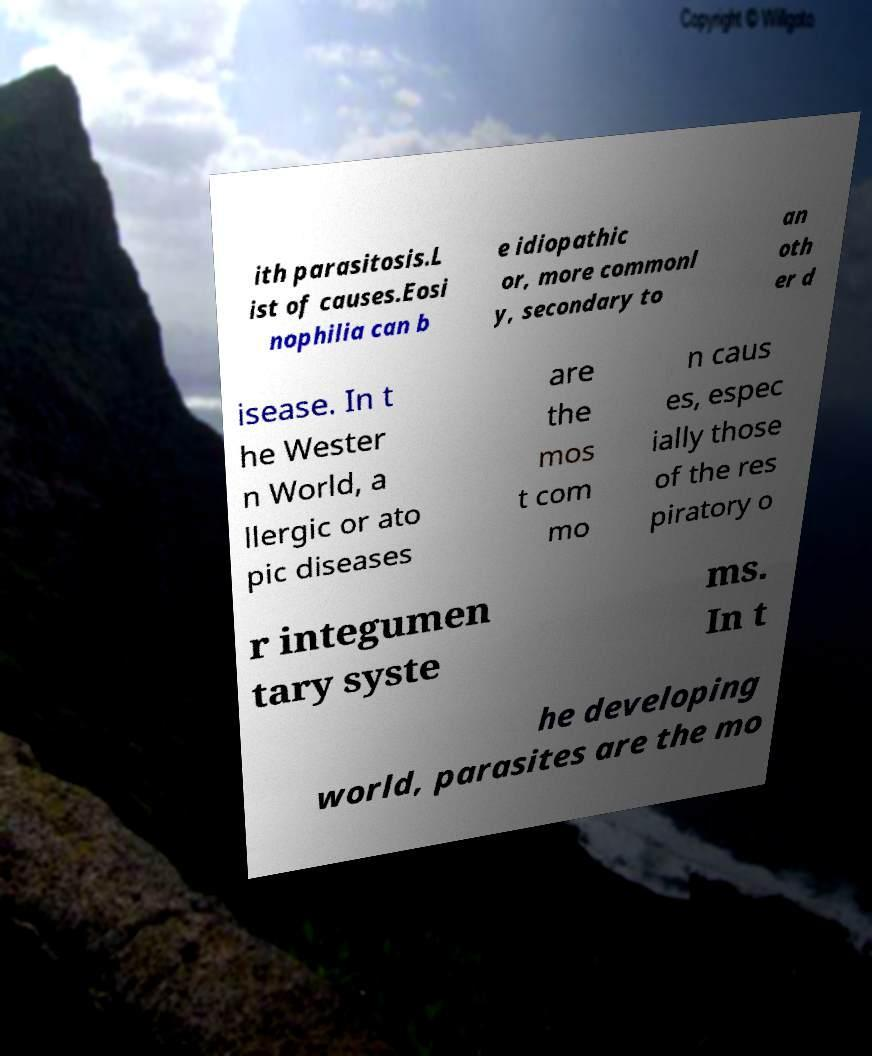Please read and relay the text visible in this image. What does it say? ith parasitosis.L ist of causes.Eosi nophilia can b e idiopathic or, more commonl y, secondary to an oth er d isease. In t he Wester n World, a llergic or ato pic diseases are the mos t com mo n caus es, espec ially those of the res piratory o r integumen tary syste ms. In t he developing world, parasites are the mo 